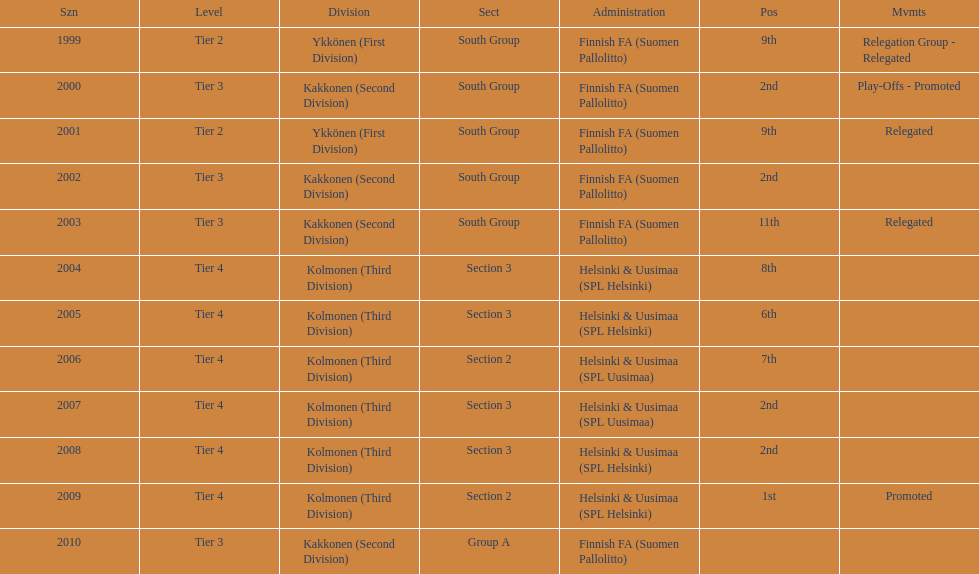Of the third division, how many were in section3? 4. 